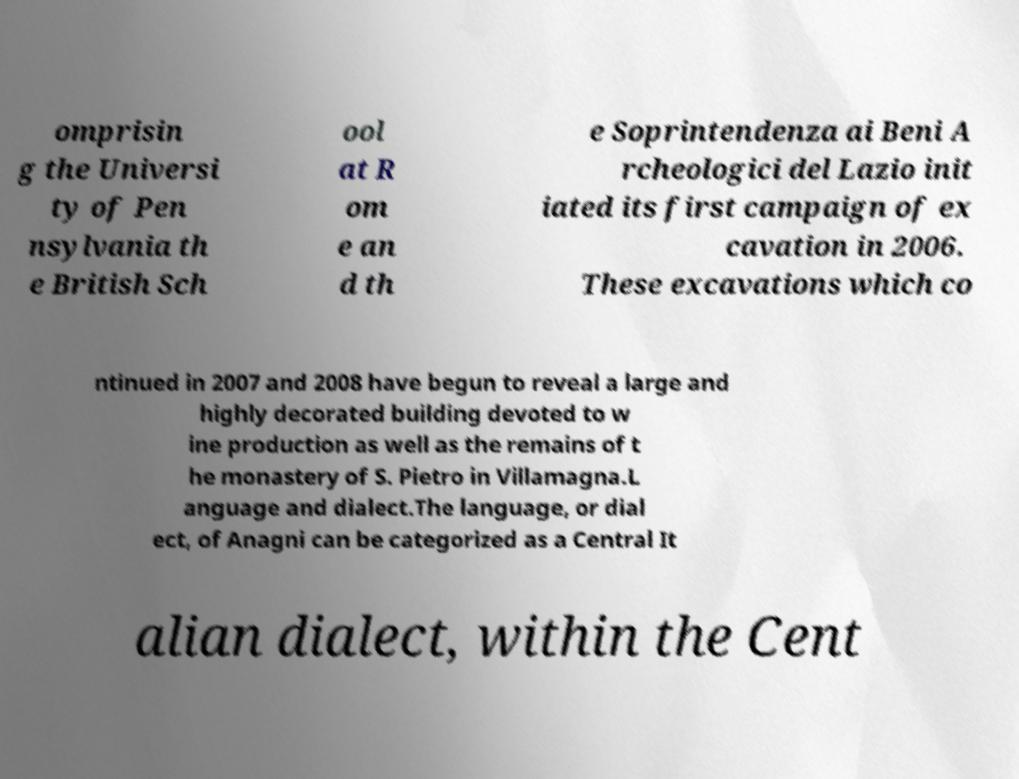Can you read and provide the text displayed in the image?This photo seems to have some interesting text. Can you extract and type it out for me? omprisin g the Universi ty of Pen nsylvania th e British Sch ool at R om e an d th e Soprintendenza ai Beni A rcheologici del Lazio init iated its first campaign of ex cavation in 2006. These excavations which co ntinued in 2007 and 2008 have begun to reveal a large and highly decorated building devoted to w ine production as well as the remains of t he monastery of S. Pietro in Villamagna.L anguage and dialect.The language, or dial ect, of Anagni can be categorized as a Central It alian dialect, within the Cent 